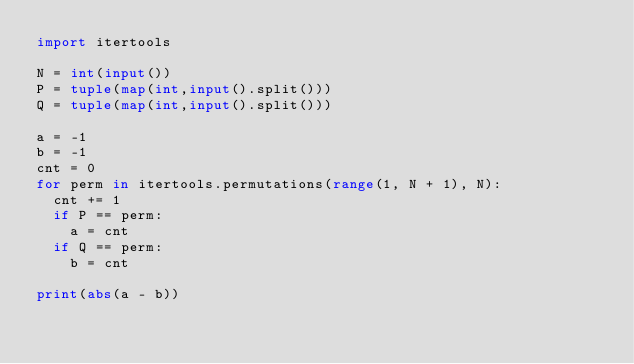Convert code to text. <code><loc_0><loc_0><loc_500><loc_500><_Python_>import itertools

N = int(input())
P = tuple(map(int,input().split()))
Q = tuple(map(int,input().split()))

a = -1
b = -1
cnt = 0
for perm in itertools.permutations(range(1, N + 1), N):
  cnt += 1
  if P == perm:
    a = cnt
  if Q == perm:
    b = cnt
    
print(abs(a - b))</code> 